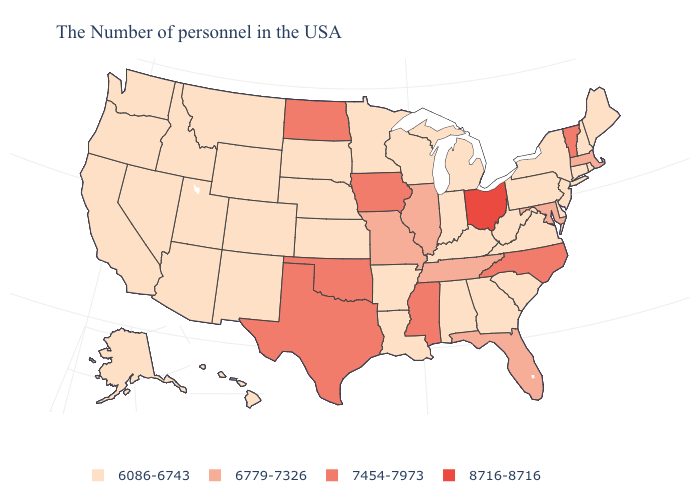Name the states that have a value in the range 8716-8716?
Concise answer only. Ohio. What is the value of South Carolina?
Be succinct. 6086-6743. Does Alaska have the lowest value in the USA?
Short answer required. Yes. Among the states that border Maine , which have the highest value?
Concise answer only. New Hampshire. Does Oregon have a lower value than Oklahoma?
Short answer required. Yes. What is the value of Iowa?
Quick response, please. 7454-7973. What is the value of Arizona?
Short answer required. 6086-6743. What is the value of Ohio?
Answer briefly. 8716-8716. Does Vermont have the lowest value in the Northeast?
Keep it brief. No. Name the states that have a value in the range 7454-7973?
Keep it brief. Vermont, North Carolina, Mississippi, Iowa, Oklahoma, Texas, North Dakota. What is the value of Arizona?
Answer briefly. 6086-6743. Name the states that have a value in the range 8716-8716?
Keep it brief. Ohio. Does New Mexico have a higher value than West Virginia?
Write a very short answer. No. Does Ohio have the highest value in the USA?
Concise answer only. Yes. 